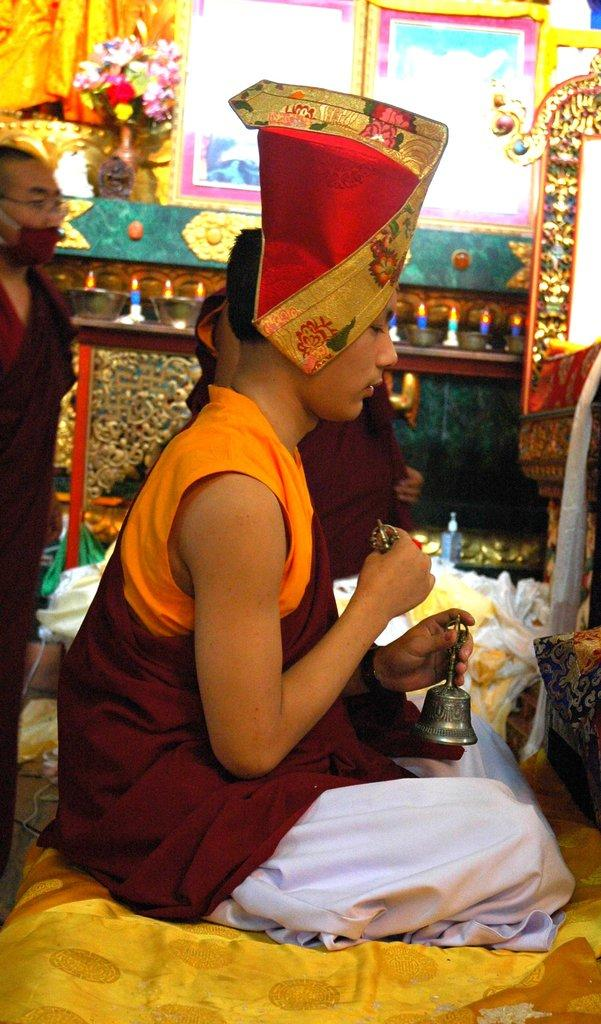What are the men in the image doing? The men in the image are sitting and standing on the floor. Can you describe the setting of the image? There are decorations, electric lights, and walls visible in the background of the image. What type of surface are the men on in the image? The men are on the floor in the image. What type of sail can be seen in the image? There is no sail present in the image. Are there any bushes visible in the image? There is no mention of bushes in the provided facts, and therefore we cannot determine if they are present in the image. 